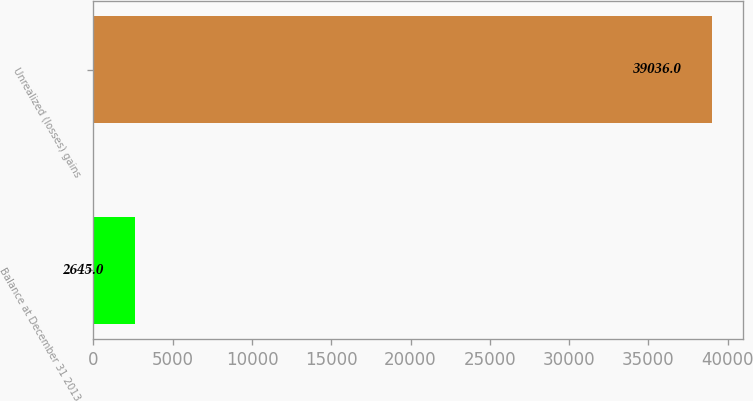Convert chart to OTSL. <chart><loc_0><loc_0><loc_500><loc_500><bar_chart><fcel>Balance at December 31 2013<fcel>Unrealized (losses) gains<nl><fcel>2645<fcel>39036<nl></chart> 